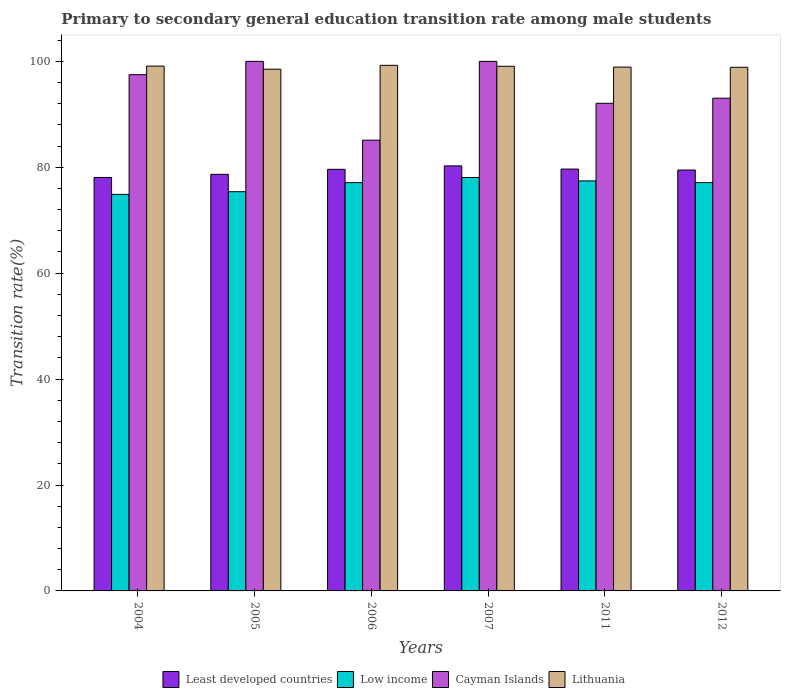How many different coloured bars are there?
Your answer should be very brief. 4. How many groups of bars are there?
Your answer should be very brief. 6. Are the number of bars per tick equal to the number of legend labels?
Provide a succinct answer. Yes. How many bars are there on the 5th tick from the right?
Make the answer very short. 4. In how many cases, is the number of bars for a given year not equal to the number of legend labels?
Keep it short and to the point. 0. What is the transition rate in Least developed countries in 2007?
Your response must be concise. 80.26. Across all years, what is the maximum transition rate in Low income?
Your answer should be very brief. 78.07. Across all years, what is the minimum transition rate in Least developed countries?
Ensure brevity in your answer.  78.08. What is the total transition rate in Lithuania in the graph?
Your answer should be very brief. 593.74. What is the difference between the transition rate in Lithuania in 2005 and that in 2007?
Your response must be concise. -0.55. What is the difference between the transition rate in Low income in 2011 and the transition rate in Cayman Islands in 2007?
Your response must be concise. -22.58. What is the average transition rate in Low income per year?
Offer a very short reply. 76.66. In the year 2004, what is the difference between the transition rate in Cayman Islands and transition rate in Lithuania?
Make the answer very short. -1.62. In how many years, is the transition rate in Lithuania greater than 40 %?
Your answer should be very brief. 6. What is the ratio of the transition rate in Least developed countries in 2006 to that in 2012?
Keep it short and to the point. 1. What is the difference between the highest and the second highest transition rate in Low income?
Your answer should be compact. 0.64. What is the difference between the highest and the lowest transition rate in Cayman Islands?
Give a very brief answer. 14.88. In how many years, is the transition rate in Cayman Islands greater than the average transition rate in Cayman Islands taken over all years?
Your response must be concise. 3. Is it the case that in every year, the sum of the transition rate in Least developed countries and transition rate in Lithuania is greater than the sum of transition rate in Cayman Islands and transition rate in Low income?
Provide a succinct answer. No. What does the 1st bar from the left in 2005 represents?
Your answer should be compact. Least developed countries. What does the 2nd bar from the right in 2012 represents?
Offer a very short reply. Cayman Islands. How many bars are there?
Make the answer very short. 24. Are the values on the major ticks of Y-axis written in scientific E-notation?
Your answer should be very brief. No. Does the graph contain grids?
Your response must be concise. No. Where does the legend appear in the graph?
Your answer should be very brief. Bottom center. How many legend labels are there?
Provide a short and direct response. 4. What is the title of the graph?
Offer a very short reply. Primary to secondary general education transition rate among male students. Does "Guatemala" appear as one of the legend labels in the graph?
Provide a succinct answer. No. What is the label or title of the Y-axis?
Give a very brief answer. Transition rate(%). What is the Transition rate(%) of Least developed countries in 2004?
Offer a very short reply. 78.08. What is the Transition rate(%) of Low income in 2004?
Offer a very short reply. 74.88. What is the Transition rate(%) in Cayman Islands in 2004?
Give a very brief answer. 97.48. What is the Transition rate(%) of Lithuania in 2004?
Keep it short and to the point. 99.1. What is the Transition rate(%) in Least developed countries in 2005?
Offer a terse response. 78.67. What is the Transition rate(%) of Low income in 2005?
Provide a succinct answer. 75.39. What is the Transition rate(%) of Cayman Islands in 2005?
Your response must be concise. 100. What is the Transition rate(%) of Lithuania in 2005?
Keep it short and to the point. 98.52. What is the Transition rate(%) of Least developed countries in 2006?
Give a very brief answer. 79.61. What is the Transition rate(%) of Low income in 2006?
Give a very brief answer. 77.1. What is the Transition rate(%) in Cayman Islands in 2006?
Make the answer very short. 85.12. What is the Transition rate(%) in Lithuania in 2006?
Offer a terse response. 99.25. What is the Transition rate(%) of Least developed countries in 2007?
Provide a short and direct response. 80.26. What is the Transition rate(%) in Low income in 2007?
Your response must be concise. 78.07. What is the Transition rate(%) of Cayman Islands in 2007?
Offer a terse response. 100. What is the Transition rate(%) in Lithuania in 2007?
Make the answer very short. 99.07. What is the Transition rate(%) of Least developed countries in 2011?
Keep it short and to the point. 79.66. What is the Transition rate(%) in Low income in 2011?
Your answer should be very brief. 77.42. What is the Transition rate(%) of Cayman Islands in 2011?
Provide a succinct answer. 92.08. What is the Transition rate(%) in Lithuania in 2011?
Make the answer very short. 98.91. What is the Transition rate(%) of Least developed countries in 2012?
Keep it short and to the point. 79.48. What is the Transition rate(%) of Low income in 2012?
Offer a terse response. 77.1. What is the Transition rate(%) of Cayman Islands in 2012?
Your answer should be very brief. 93.04. What is the Transition rate(%) in Lithuania in 2012?
Your answer should be very brief. 98.88. Across all years, what is the maximum Transition rate(%) of Least developed countries?
Provide a short and direct response. 80.26. Across all years, what is the maximum Transition rate(%) in Low income?
Provide a short and direct response. 78.07. Across all years, what is the maximum Transition rate(%) of Lithuania?
Your response must be concise. 99.25. Across all years, what is the minimum Transition rate(%) of Least developed countries?
Give a very brief answer. 78.08. Across all years, what is the minimum Transition rate(%) in Low income?
Offer a very short reply. 74.88. Across all years, what is the minimum Transition rate(%) in Cayman Islands?
Your response must be concise. 85.12. Across all years, what is the minimum Transition rate(%) in Lithuania?
Give a very brief answer. 98.52. What is the total Transition rate(%) in Least developed countries in the graph?
Offer a very short reply. 475.76. What is the total Transition rate(%) of Low income in the graph?
Keep it short and to the point. 459.96. What is the total Transition rate(%) of Cayman Islands in the graph?
Give a very brief answer. 567.72. What is the total Transition rate(%) of Lithuania in the graph?
Make the answer very short. 593.74. What is the difference between the Transition rate(%) of Least developed countries in 2004 and that in 2005?
Make the answer very short. -0.59. What is the difference between the Transition rate(%) in Low income in 2004 and that in 2005?
Your response must be concise. -0.51. What is the difference between the Transition rate(%) in Cayman Islands in 2004 and that in 2005?
Give a very brief answer. -2.52. What is the difference between the Transition rate(%) of Lithuania in 2004 and that in 2005?
Ensure brevity in your answer.  0.58. What is the difference between the Transition rate(%) of Least developed countries in 2004 and that in 2006?
Offer a very short reply. -1.54. What is the difference between the Transition rate(%) in Low income in 2004 and that in 2006?
Offer a terse response. -2.22. What is the difference between the Transition rate(%) in Cayman Islands in 2004 and that in 2006?
Give a very brief answer. 12.37. What is the difference between the Transition rate(%) of Lithuania in 2004 and that in 2006?
Your answer should be compact. -0.15. What is the difference between the Transition rate(%) in Least developed countries in 2004 and that in 2007?
Offer a terse response. -2.19. What is the difference between the Transition rate(%) in Low income in 2004 and that in 2007?
Keep it short and to the point. -3.19. What is the difference between the Transition rate(%) in Cayman Islands in 2004 and that in 2007?
Offer a terse response. -2.52. What is the difference between the Transition rate(%) in Lithuania in 2004 and that in 2007?
Your answer should be very brief. 0.03. What is the difference between the Transition rate(%) of Least developed countries in 2004 and that in 2011?
Offer a terse response. -1.59. What is the difference between the Transition rate(%) of Low income in 2004 and that in 2011?
Offer a terse response. -2.54. What is the difference between the Transition rate(%) of Cayman Islands in 2004 and that in 2011?
Make the answer very short. 5.4. What is the difference between the Transition rate(%) in Lithuania in 2004 and that in 2011?
Your answer should be compact. 0.19. What is the difference between the Transition rate(%) in Least developed countries in 2004 and that in 2012?
Keep it short and to the point. -1.4. What is the difference between the Transition rate(%) of Low income in 2004 and that in 2012?
Offer a terse response. -2.23. What is the difference between the Transition rate(%) of Cayman Islands in 2004 and that in 2012?
Your answer should be compact. 4.44. What is the difference between the Transition rate(%) of Lithuania in 2004 and that in 2012?
Keep it short and to the point. 0.22. What is the difference between the Transition rate(%) of Least developed countries in 2005 and that in 2006?
Your answer should be very brief. -0.94. What is the difference between the Transition rate(%) in Low income in 2005 and that in 2006?
Your response must be concise. -1.72. What is the difference between the Transition rate(%) of Cayman Islands in 2005 and that in 2006?
Your answer should be very brief. 14.88. What is the difference between the Transition rate(%) in Lithuania in 2005 and that in 2006?
Make the answer very short. -0.73. What is the difference between the Transition rate(%) of Least developed countries in 2005 and that in 2007?
Provide a succinct answer. -1.59. What is the difference between the Transition rate(%) of Low income in 2005 and that in 2007?
Give a very brief answer. -2.68. What is the difference between the Transition rate(%) in Lithuania in 2005 and that in 2007?
Offer a terse response. -0.55. What is the difference between the Transition rate(%) of Least developed countries in 2005 and that in 2011?
Provide a succinct answer. -0.99. What is the difference between the Transition rate(%) of Low income in 2005 and that in 2011?
Keep it short and to the point. -2.04. What is the difference between the Transition rate(%) in Cayman Islands in 2005 and that in 2011?
Your answer should be very brief. 7.92. What is the difference between the Transition rate(%) in Lithuania in 2005 and that in 2011?
Your answer should be compact. -0.39. What is the difference between the Transition rate(%) of Least developed countries in 2005 and that in 2012?
Ensure brevity in your answer.  -0.81. What is the difference between the Transition rate(%) of Low income in 2005 and that in 2012?
Give a very brief answer. -1.72. What is the difference between the Transition rate(%) of Cayman Islands in 2005 and that in 2012?
Your answer should be very brief. 6.96. What is the difference between the Transition rate(%) in Lithuania in 2005 and that in 2012?
Offer a terse response. -0.36. What is the difference between the Transition rate(%) of Least developed countries in 2006 and that in 2007?
Keep it short and to the point. -0.65. What is the difference between the Transition rate(%) of Low income in 2006 and that in 2007?
Provide a succinct answer. -0.96. What is the difference between the Transition rate(%) in Cayman Islands in 2006 and that in 2007?
Your answer should be very brief. -14.88. What is the difference between the Transition rate(%) of Lithuania in 2006 and that in 2007?
Provide a short and direct response. 0.18. What is the difference between the Transition rate(%) in Least developed countries in 2006 and that in 2011?
Offer a terse response. -0.05. What is the difference between the Transition rate(%) of Low income in 2006 and that in 2011?
Ensure brevity in your answer.  -0.32. What is the difference between the Transition rate(%) in Cayman Islands in 2006 and that in 2011?
Give a very brief answer. -6.97. What is the difference between the Transition rate(%) of Lithuania in 2006 and that in 2011?
Provide a short and direct response. 0.34. What is the difference between the Transition rate(%) of Least developed countries in 2006 and that in 2012?
Make the answer very short. 0.13. What is the difference between the Transition rate(%) in Low income in 2006 and that in 2012?
Offer a very short reply. -0. What is the difference between the Transition rate(%) in Cayman Islands in 2006 and that in 2012?
Give a very brief answer. -7.93. What is the difference between the Transition rate(%) in Lithuania in 2006 and that in 2012?
Offer a terse response. 0.37. What is the difference between the Transition rate(%) in Least developed countries in 2007 and that in 2011?
Keep it short and to the point. 0.6. What is the difference between the Transition rate(%) in Low income in 2007 and that in 2011?
Your answer should be compact. 0.64. What is the difference between the Transition rate(%) of Cayman Islands in 2007 and that in 2011?
Provide a succinct answer. 7.92. What is the difference between the Transition rate(%) of Lithuania in 2007 and that in 2011?
Offer a very short reply. 0.15. What is the difference between the Transition rate(%) of Least developed countries in 2007 and that in 2012?
Offer a terse response. 0.78. What is the difference between the Transition rate(%) in Low income in 2007 and that in 2012?
Your answer should be very brief. 0.96. What is the difference between the Transition rate(%) in Cayman Islands in 2007 and that in 2012?
Your answer should be compact. 6.96. What is the difference between the Transition rate(%) of Lithuania in 2007 and that in 2012?
Offer a very short reply. 0.19. What is the difference between the Transition rate(%) of Least developed countries in 2011 and that in 2012?
Offer a terse response. 0.18. What is the difference between the Transition rate(%) of Low income in 2011 and that in 2012?
Your answer should be very brief. 0.32. What is the difference between the Transition rate(%) of Cayman Islands in 2011 and that in 2012?
Your answer should be very brief. -0.96. What is the difference between the Transition rate(%) of Lithuania in 2011 and that in 2012?
Offer a terse response. 0.03. What is the difference between the Transition rate(%) of Least developed countries in 2004 and the Transition rate(%) of Low income in 2005?
Make the answer very short. 2.69. What is the difference between the Transition rate(%) in Least developed countries in 2004 and the Transition rate(%) in Cayman Islands in 2005?
Your answer should be compact. -21.93. What is the difference between the Transition rate(%) in Least developed countries in 2004 and the Transition rate(%) in Lithuania in 2005?
Make the answer very short. -20.45. What is the difference between the Transition rate(%) in Low income in 2004 and the Transition rate(%) in Cayman Islands in 2005?
Your response must be concise. -25.12. What is the difference between the Transition rate(%) in Low income in 2004 and the Transition rate(%) in Lithuania in 2005?
Offer a very short reply. -23.64. What is the difference between the Transition rate(%) of Cayman Islands in 2004 and the Transition rate(%) of Lithuania in 2005?
Provide a succinct answer. -1.04. What is the difference between the Transition rate(%) in Least developed countries in 2004 and the Transition rate(%) in Low income in 2006?
Give a very brief answer. 0.97. What is the difference between the Transition rate(%) of Least developed countries in 2004 and the Transition rate(%) of Cayman Islands in 2006?
Provide a short and direct response. -7.04. What is the difference between the Transition rate(%) in Least developed countries in 2004 and the Transition rate(%) in Lithuania in 2006?
Make the answer very short. -21.18. What is the difference between the Transition rate(%) in Low income in 2004 and the Transition rate(%) in Cayman Islands in 2006?
Provide a succinct answer. -10.24. What is the difference between the Transition rate(%) of Low income in 2004 and the Transition rate(%) of Lithuania in 2006?
Your answer should be very brief. -24.37. What is the difference between the Transition rate(%) in Cayman Islands in 2004 and the Transition rate(%) in Lithuania in 2006?
Keep it short and to the point. -1.77. What is the difference between the Transition rate(%) of Least developed countries in 2004 and the Transition rate(%) of Low income in 2007?
Offer a very short reply. 0.01. What is the difference between the Transition rate(%) in Least developed countries in 2004 and the Transition rate(%) in Cayman Islands in 2007?
Provide a succinct answer. -21.93. What is the difference between the Transition rate(%) in Least developed countries in 2004 and the Transition rate(%) in Lithuania in 2007?
Offer a very short reply. -20.99. What is the difference between the Transition rate(%) in Low income in 2004 and the Transition rate(%) in Cayman Islands in 2007?
Provide a short and direct response. -25.12. What is the difference between the Transition rate(%) in Low income in 2004 and the Transition rate(%) in Lithuania in 2007?
Give a very brief answer. -24.19. What is the difference between the Transition rate(%) in Cayman Islands in 2004 and the Transition rate(%) in Lithuania in 2007?
Keep it short and to the point. -1.58. What is the difference between the Transition rate(%) of Least developed countries in 2004 and the Transition rate(%) of Low income in 2011?
Provide a succinct answer. 0.65. What is the difference between the Transition rate(%) of Least developed countries in 2004 and the Transition rate(%) of Cayman Islands in 2011?
Make the answer very short. -14.01. What is the difference between the Transition rate(%) of Least developed countries in 2004 and the Transition rate(%) of Lithuania in 2011?
Provide a short and direct response. -20.84. What is the difference between the Transition rate(%) in Low income in 2004 and the Transition rate(%) in Cayman Islands in 2011?
Offer a very short reply. -17.2. What is the difference between the Transition rate(%) of Low income in 2004 and the Transition rate(%) of Lithuania in 2011?
Keep it short and to the point. -24.03. What is the difference between the Transition rate(%) in Cayman Islands in 2004 and the Transition rate(%) in Lithuania in 2011?
Ensure brevity in your answer.  -1.43. What is the difference between the Transition rate(%) in Least developed countries in 2004 and the Transition rate(%) in Low income in 2012?
Provide a short and direct response. 0.97. What is the difference between the Transition rate(%) of Least developed countries in 2004 and the Transition rate(%) of Cayman Islands in 2012?
Keep it short and to the point. -14.97. What is the difference between the Transition rate(%) in Least developed countries in 2004 and the Transition rate(%) in Lithuania in 2012?
Ensure brevity in your answer.  -20.81. What is the difference between the Transition rate(%) in Low income in 2004 and the Transition rate(%) in Cayman Islands in 2012?
Make the answer very short. -18.16. What is the difference between the Transition rate(%) in Low income in 2004 and the Transition rate(%) in Lithuania in 2012?
Your answer should be compact. -24. What is the difference between the Transition rate(%) in Cayman Islands in 2004 and the Transition rate(%) in Lithuania in 2012?
Offer a terse response. -1.4. What is the difference between the Transition rate(%) of Least developed countries in 2005 and the Transition rate(%) of Low income in 2006?
Provide a short and direct response. 1.57. What is the difference between the Transition rate(%) in Least developed countries in 2005 and the Transition rate(%) in Cayman Islands in 2006?
Offer a terse response. -6.45. What is the difference between the Transition rate(%) of Least developed countries in 2005 and the Transition rate(%) of Lithuania in 2006?
Your answer should be compact. -20.58. What is the difference between the Transition rate(%) in Low income in 2005 and the Transition rate(%) in Cayman Islands in 2006?
Keep it short and to the point. -9.73. What is the difference between the Transition rate(%) in Low income in 2005 and the Transition rate(%) in Lithuania in 2006?
Provide a short and direct response. -23.87. What is the difference between the Transition rate(%) of Cayman Islands in 2005 and the Transition rate(%) of Lithuania in 2006?
Your answer should be very brief. 0.75. What is the difference between the Transition rate(%) in Least developed countries in 2005 and the Transition rate(%) in Low income in 2007?
Make the answer very short. 0.6. What is the difference between the Transition rate(%) in Least developed countries in 2005 and the Transition rate(%) in Cayman Islands in 2007?
Offer a very short reply. -21.33. What is the difference between the Transition rate(%) of Least developed countries in 2005 and the Transition rate(%) of Lithuania in 2007?
Ensure brevity in your answer.  -20.4. What is the difference between the Transition rate(%) in Low income in 2005 and the Transition rate(%) in Cayman Islands in 2007?
Your response must be concise. -24.61. What is the difference between the Transition rate(%) of Low income in 2005 and the Transition rate(%) of Lithuania in 2007?
Make the answer very short. -23.68. What is the difference between the Transition rate(%) of Cayman Islands in 2005 and the Transition rate(%) of Lithuania in 2007?
Your answer should be very brief. 0.93. What is the difference between the Transition rate(%) of Least developed countries in 2005 and the Transition rate(%) of Low income in 2011?
Your response must be concise. 1.25. What is the difference between the Transition rate(%) of Least developed countries in 2005 and the Transition rate(%) of Cayman Islands in 2011?
Your answer should be very brief. -13.41. What is the difference between the Transition rate(%) of Least developed countries in 2005 and the Transition rate(%) of Lithuania in 2011?
Your response must be concise. -20.25. What is the difference between the Transition rate(%) in Low income in 2005 and the Transition rate(%) in Cayman Islands in 2011?
Your answer should be very brief. -16.7. What is the difference between the Transition rate(%) in Low income in 2005 and the Transition rate(%) in Lithuania in 2011?
Ensure brevity in your answer.  -23.53. What is the difference between the Transition rate(%) in Cayman Islands in 2005 and the Transition rate(%) in Lithuania in 2011?
Make the answer very short. 1.09. What is the difference between the Transition rate(%) of Least developed countries in 2005 and the Transition rate(%) of Low income in 2012?
Your response must be concise. 1.56. What is the difference between the Transition rate(%) in Least developed countries in 2005 and the Transition rate(%) in Cayman Islands in 2012?
Give a very brief answer. -14.37. What is the difference between the Transition rate(%) in Least developed countries in 2005 and the Transition rate(%) in Lithuania in 2012?
Your answer should be very brief. -20.21. What is the difference between the Transition rate(%) of Low income in 2005 and the Transition rate(%) of Cayman Islands in 2012?
Provide a succinct answer. -17.66. What is the difference between the Transition rate(%) of Low income in 2005 and the Transition rate(%) of Lithuania in 2012?
Make the answer very short. -23.5. What is the difference between the Transition rate(%) in Cayman Islands in 2005 and the Transition rate(%) in Lithuania in 2012?
Your answer should be very brief. 1.12. What is the difference between the Transition rate(%) of Least developed countries in 2006 and the Transition rate(%) of Low income in 2007?
Your answer should be very brief. 1.55. What is the difference between the Transition rate(%) of Least developed countries in 2006 and the Transition rate(%) of Cayman Islands in 2007?
Your answer should be compact. -20.39. What is the difference between the Transition rate(%) of Least developed countries in 2006 and the Transition rate(%) of Lithuania in 2007?
Provide a short and direct response. -19.46. What is the difference between the Transition rate(%) of Low income in 2006 and the Transition rate(%) of Cayman Islands in 2007?
Keep it short and to the point. -22.9. What is the difference between the Transition rate(%) in Low income in 2006 and the Transition rate(%) in Lithuania in 2007?
Your response must be concise. -21.97. What is the difference between the Transition rate(%) of Cayman Islands in 2006 and the Transition rate(%) of Lithuania in 2007?
Provide a short and direct response. -13.95. What is the difference between the Transition rate(%) in Least developed countries in 2006 and the Transition rate(%) in Low income in 2011?
Your answer should be very brief. 2.19. What is the difference between the Transition rate(%) in Least developed countries in 2006 and the Transition rate(%) in Cayman Islands in 2011?
Your answer should be compact. -12.47. What is the difference between the Transition rate(%) of Least developed countries in 2006 and the Transition rate(%) of Lithuania in 2011?
Your answer should be very brief. -19.3. What is the difference between the Transition rate(%) in Low income in 2006 and the Transition rate(%) in Cayman Islands in 2011?
Offer a very short reply. -14.98. What is the difference between the Transition rate(%) in Low income in 2006 and the Transition rate(%) in Lithuania in 2011?
Your answer should be very brief. -21.81. What is the difference between the Transition rate(%) of Cayman Islands in 2006 and the Transition rate(%) of Lithuania in 2011?
Provide a succinct answer. -13.8. What is the difference between the Transition rate(%) of Least developed countries in 2006 and the Transition rate(%) of Low income in 2012?
Provide a succinct answer. 2.51. What is the difference between the Transition rate(%) of Least developed countries in 2006 and the Transition rate(%) of Cayman Islands in 2012?
Ensure brevity in your answer.  -13.43. What is the difference between the Transition rate(%) of Least developed countries in 2006 and the Transition rate(%) of Lithuania in 2012?
Keep it short and to the point. -19.27. What is the difference between the Transition rate(%) of Low income in 2006 and the Transition rate(%) of Cayman Islands in 2012?
Give a very brief answer. -15.94. What is the difference between the Transition rate(%) of Low income in 2006 and the Transition rate(%) of Lithuania in 2012?
Offer a terse response. -21.78. What is the difference between the Transition rate(%) in Cayman Islands in 2006 and the Transition rate(%) in Lithuania in 2012?
Offer a terse response. -13.76. What is the difference between the Transition rate(%) of Least developed countries in 2007 and the Transition rate(%) of Low income in 2011?
Your answer should be compact. 2.84. What is the difference between the Transition rate(%) in Least developed countries in 2007 and the Transition rate(%) in Cayman Islands in 2011?
Your response must be concise. -11.82. What is the difference between the Transition rate(%) in Least developed countries in 2007 and the Transition rate(%) in Lithuania in 2011?
Offer a terse response. -18.65. What is the difference between the Transition rate(%) in Low income in 2007 and the Transition rate(%) in Cayman Islands in 2011?
Make the answer very short. -14.02. What is the difference between the Transition rate(%) of Low income in 2007 and the Transition rate(%) of Lithuania in 2011?
Make the answer very short. -20.85. What is the difference between the Transition rate(%) of Cayman Islands in 2007 and the Transition rate(%) of Lithuania in 2011?
Ensure brevity in your answer.  1.09. What is the difference between the Transition rate(%) of Least developed countries in 2007 and the Transition rate(%) of Low income in 2012?
Provide a short and direct response. 3.16. What is the difference between the Transition rate(%) of Least developed countries in 2007 and the Transition rate(%) of Cayman Islands in 2012?
Ensure brevity in your answer.  -12.78. What is the difference between the Transition rate(%) of Least developed countries in 2007 and the Transition rate(%) of Lithuania in 2012?
Provide a succinct answer. -18.62. What is the difference between the Transition rate(%) in Low income in 2007 and the Transition rate(%) in Cayman Islands in 2012?
Ensure brevity in your answer.  -14.98. What is the difference between the Transition rate(%) in Low income in 2007 and the Transition rate(%) in Lithuania in 2012?
Your response must be concise. -20.81. What is the difference between the Transition rate(%) in Cayman Islands in 2007 and the Transition rate(%) in Lithuania in 2012?
Your answer should be compact. 1.12. What is the difference between the Transition rate(%) in Least developed countries in 2011 and the Transition rate(%) in Low income in 2012?
Provide a succinct answer. 2.56. What is the difference between the Transition rate(%) of Least developed countries in 2011 and the Transition rate(%) of Cayman Islands in 2012?
Provide a succinct answer. -13.38. What is the difference between the Transition rate(%) of Least developed countries in 2011 and the Transition rate(%) of Lithuania in 2012?
Ensure brevity in your answer.  -19.22. What is the difference between the Transition rate(%) of Low income in 2011 and the Transition rate(%) of Cayman Islands in 2012?
Provide a succinct answer. -15.62. What is the difference between the Transition rate(%) of Low income in 2011 and the Transition rate(%) of Lithuania in 2012?
Give a very brief answer. -21.46. What is the difference between the Transition rate(%) in Cayman Islands in 2011 and the Transition rate(%) in Lithuania in 2012?
Provide a succinct answer. -6.8. What is the average Transition rate(%) in Least developed countries per year?
Ensure brevity in your answer.  79.29. What is the average Transition rate(%) of Low income per year?
Your response must be concise. 76.66. What is the average Transition rate(%) in Cayman Islands per year?
Your response must be concise. 94.62. What is the average Transition rate(%) in Lithuania per year?
Your answer should be very brief. 98.96. In the year 2004, what is the difference between the Transition rate(%) in Least developed countries and Transition rate(%) in Low income?
Make the answer very short. 3.2. In the year 2004, what is the difference between the Transition rate(%) of Least developed countries and Transition rate(%) of Cayman Islands?
Your answer should be compact. -19.41. In the year 2004, what is the difference between the Transition rate(%) in Least developed countries and Transition rate(%) in Lithuania?
Your answer should be compact. -21.03. In the year 2004, what is the difference between the Transition rate(%) of Low income and Transition rate(%) of Cayman Islands?
Provide a short and direct response. -22.6. In the year 2004, what is the difference between the Transition rate(%) of Low income and Transition rate(%) of Lithuania?
Make the answer very short. -24.22. In the year 2004, what is the difference between the Transition rate(%) of Cayman Islands and Transition rate(%) of Lithuania?
Your answer should be very brief. -1.62. In the year 2005, what is the difference between the Transition rate(%) in Least developed countries and Transition rate(%) in Low income?
Your answer should be compact. 3.28. In the year 2005, what is the difference between the Transition rate(%) in Least developed countries and Transition rate(%) in Cayman Islands?
Your answer should be very brief. -21.33. In the year 2005, what is the difference between the Transition rate(%) of Least developed countries and Transition rate(%) of Lithuania?
Your answer should be very brief. -19.85. In the year 2005, what is the difference between the Transition rate(%) in Low income and Transition rate(%) in Cayman Islands?
Your response must be concise. -24.61. In the year 2005, what is the difference between the Transition rate(%) in Low income and Transition rate(%) in Lithuania?
Provide a succinct answer. -23.14. In the year 2005, what is the difference between the Transition rate(%) in Cayman Islands and Transition rate(%) in Lithuania?
Your answer should be very brief. 1.48. In the year 2006, what is the difference between the Transition rate(%) of Least developed countries and Transition rate(%) of Low income?
Your answer should be compact. 2.51. In the year 2006, what is the difference between the Transition rate(%) in Least developed countries and Transition rate(%) in Cayman Islands?
Ensure brevity in your answer.  -5.5. In the year 2006, what is the difference between the Transition rate(%) of Least developed countries and Transition rate(%) of Lithuania?
Your answer should be very brief. -19.64. In the year 2006, what is the difference between the Transition rate(%) of Low income and Transition rate(%) of Cayman Islands?
Ensure brevity in your answer.  -8.01. In the year 2006, what is the difference between the Transition rate(%) in Low income and Transition rate(%) in Lithuania?
Provide a succinct answer. -22.15. In the year 2006, what is the difference between the Transition rate(%) of Cayman Islands and Transition rate(%) of Lithuania?
Provide a short and direct response. -14.14. In the year 2007, what is the difference between the Transition rate(%) in Least developed countries and Transition rate(%) in Low income?
Your response must be concise. 2.2. In the year 2007, what is the difference between the Transition rate(%) of Least developed countries and Transition rate(%) of Cayman Islands?
Give a very brief answer. -19.74. In the year 2007, what is the difference between the Transition rate(%) in Least developed countries and Transition rate(%) in Lithuania?
Give a very brief answer. -18.81. In the year 2007, what is the difference between the Transition rate(%) of Low income and Transition rate(%) of Cayman Islands?
Your response must be concise. -21.93. In the year 2007, what is the difference between the Transition rate(%) in Low income and Transition rate(%) in Lithuania?
Offer a terse response. -21. In the year 2007, what is the difference between the Transition rate(%) of Cayman Islands and Transition rate(%) of Lithuania?
Your response must be concise. 0.93. In the year 2011, what is the difference between the Transition rate(%) of Least developed countries and Transition rate(%) of Low income?
Your response must be concise. 2.24. In the year 2011, what is the difference between the Transition rate(%) in Least developed countries and Transition rate(%) in Cayman Islands?
Keep it short and to the point. -12.42. In the year 2011, what is the difference between the Transition rate(%) in Least developed countries and Transition rate(%) in Lithuania?
Offer a very short reply. -19.25. In the year 2011, what is the difference between the Transition rate(%) of Low income and Transition rate(%) of Cayman Islands?
Your answer should be compact. -14.66. In the year 2011, what is the difference between the Transition rate(%) in Low income and Transition rate(%) in Lithuania?
Your response must be concise. -21.49. In the year 2011, what is the difference between the Transition rate(%) of Cayman Islands and Transition rate(%) of Lithuania?
Your response must be concise. -6.83. In the year 2012, what is the difference between the Transition rate(%) of Least developed countries and Transition rate(%) of Low income?
Keep it short and to the point. 2.37. In the year 2012, what is the difference between the Transition rate(%) in Least developed countries and Transition rate(%) in Cayman Islands?
Your answer should be very brief. -13.56. In the year 2012, what is the difference between the Transition rate(%) in Least developed countries and Transition rate(%) in Lithuania?
Your response must be concise. -19.4. In the year 2012, what is the difference between the Transition rate(%) in Low income and Transition rate(%) in Cayman Islands?
Your response must be concise. -15.94. In the year 2012, what is the difference between the Transition rate(%) in Low income and Transition rate(%) in Lithuania?
Your answer should be compact. -21.78. In the year 2012, what is the difference between the Transition rate(%) of Cayman Islands and Transition rate(%) of Lithuania?
Keep it short and to the point. -5.84. What is the ratio of the Transition rate(%) of Least developed countries in 2004 to that in 2005?
Your response must be concise. 0.99. What is the ratio of the Transition rate(%) of Cayman Islands in 2004 to that in 2005?
Ensure brevity in your answer.  0.97. What is the ratio of the Transition rate(%) of Lithuania in 2004 to that in 2005?
Provide a succinct answer. 1.01. What is the ratio of the Transition rate(%) of Least developed countries in 2004 to that in 2006?
Offer a terse response. 0.98. What is the ratio of the Transition rate(%) in Low income in 2004 to that in 2006?
Your response must be concise. 0.97. What is the ratio of the Transition rate(%) in Cayman Islands in 2004 to that in 2006?
Keep it short and to the point. 1.15. What is the ratio of the Transition rate(%) of Lithuania in 2004 to that in 2006?
Offer a terse response. 1. What is the ratio of the Transition rate(%) of Least developed countries in 2004 to that in 2007?
Your answer should be very brief. 0.97. What is the ratio of the Transition rate(%) of Low income in 2004 to that in 2007?
Your answer should be compact. 0.96. What is the ratio of the Transition rate(%) of Cayman Islands in 2004 to that in 2007?
Keep it short and to the point. 0.97. What is the ratio of the Transition rate(%) in Lithuania in 2004 to that in 2007?
Provide a succinct answer. 1. What is the ratio of the Transition rate(%) in Least developed countries in 2004 to that in 2011?
Your response must be concise. 0.98. What is the ratio of the Transition rate(%) in Low income in 2004 to that in 2011?
Offer a terse response. 0.97. What is the ratio of the Transition rate(%) in Cayman Islands in 2004 to that in 2011?
Keep it short and to the point. 1.06. What is the ratio of the Transition rate(%) in Lithuania in 2004 to that in 2011?
Offer a terse response. 1. What is the ratio of the Transition rate(%) of Least developed countries in 2004 to that in 2012?
Offer a terse response. 0.98. What is the ratio of the Transition rate(%) of Low income in 2004 to that in 2012?
Provide a short and direct response. 0.97. What is the ratio of the Transition rate(%) in Cayman Islands in 2004 to that in 2012?
Give a very brief answer. 1.05. What is the ratio of the Transition rate(%) of Low income in 2005 to that in 2006?
Ensure brevity in your answer.  0.98. What is the ratio of the Transition rate(%) in Cayman Islands in 2005 to that in 2006?
Give a very brief answer. 1.17. What is the ratio of the Transition rate(%) of Lithuania in 2005 to that in 2006?
Provide a short and direct response. 0.99. What is the ratio of the Transition rate(%) of Least developed countries in 2005 to that in 2007?
Keep it short and to the point. 0.98. What is the ratio of the Transition rate(%) of Low income in 2005 to that in 2007?
Keep it short and to the point. 0.97. What is the ratio of the Transition rate(%) of Cayman Islands in 2005 to that in 2007?
Your answer should be very brief. 1. What is the ratio of the Transition rate(%) of Least developed countries in 2005 to that in 2011?
Your answer should be very brief. 0.99. What is the ratio of the Transition rate(%) in Low income in 2005 to that in 2011?
Your answer should be very brief. 0.97. What is the ratio of the Transition rate(%) of Cayman Islands in 2005 to that in 2011?
Your answer should be compact. 1.09. What is the ratio of the Transition rate(%) in Least developed countries in 2005 to that in 2012?
Your response must be concise. 0.99. What is the ratio of the Transition rate(%) in Low income in 2005 to that in 2012?
Your answer should be very brief. 0.98. What is the ratio of the Transition rate(%) of Cayman Islands in 2005 to that in 2012?
Your response must be concise. 1.07. What is the ratio of the Transition rate(%) in Lithuania in 2005 to that in 2012?
Your answer should be compact. 1. What is the ratio of the Transition rate(%) in Least developed countries in 2006 to that in 2007?
Offer a very short reply. 0.99. What is the ratio of the Transition rate(%) in Cayman Islands in 2006 to that in 2007?
Your response must be concise. 0.85. What is the ratio of the Transition rate(%) of Low income in 2006 to that in 2011?
Provide a succinct answer. 1. What is the ratio of the Transition rate(%) of Cayman Islands in 2006 to that in 2011?
Give a very brief answer. 0.92. What is the ratio of the Transition rate(%) in Lithuania in 2006 to that in 2011?
Provide a short and direct response. 1. What is the ratio of the Transition rate(%) of Least developed countries in 2006 to that in 2012?
Your answer should be very brief. 1. What is the ratio of the Transition rate(%) of Cayman Islands in 2006 to that in 2012?
Provide a short and direct response. 0.91. What is the ratio of the Transition rate(%) of Least developed countries in 2007 to that in 2011?
Make the answer very short. 1.01. What is the ratio of the Transition rate(%) of Low income in 2007 to that in 2011?
Offer a very short reply. 1.01. What is the ratio of the Transition rate(%) of Cayman Islands in 2007 to that in 2011?
Your answer should be very brief. 1.09. What is the ratio of the Transition rate(%) in Lithuania in 2007 to that in 2011?
Keep it short and to the point. 1. What is the ratio of the Transition rate(%) in Least developed countries in 2007 to that in 2012?
Offer a terse response. 1.01. What is the ratio of the Transition rate(%) of Low income in 2007 to that in 2012?
Give a very brief answer. 1.01. What is the ratio of the Transition rate(%) in Cayman Islands in 2007 to that in 2012?
Give a very brief answer. 1.07. What is the ratio of the Transition rate(%) in Least developed countries in 2011 to that in 2012?
Your response must be concise. 1. What is the ratio of the Transition rate(%) of Lithuania in 2011 to that in 2012?
Offer a terse response. 1. What is the difference between the highest and the second highest Transition rate(%) of Least developed countries?
Offer a terse response. 0.6. What is the difference between the highest and the second highest Transition rate(%) of Low income?
Provide a succinct answer. 0.64. What is the difference between the highest and the second highest Transition rate(%) of Lithuania?
Your answer should be very brief. 0.15. What is the difference between the highest and the lowest Transition rate(%) in Least developed countries?
Make the answer very short. 2.19. What is the difference between the highest and the lowest Transition rate(%) of Low income?
Offer a terse response. 3.19. What is the difference between the highest and the lowest Transition rate(%) in Cayman Islands?
Provide a succinct answer. 14.88. What is the difference between the highest and the lowest Transition rate(%) in Lithuania?
Provide a short and direct response. 0.73. 